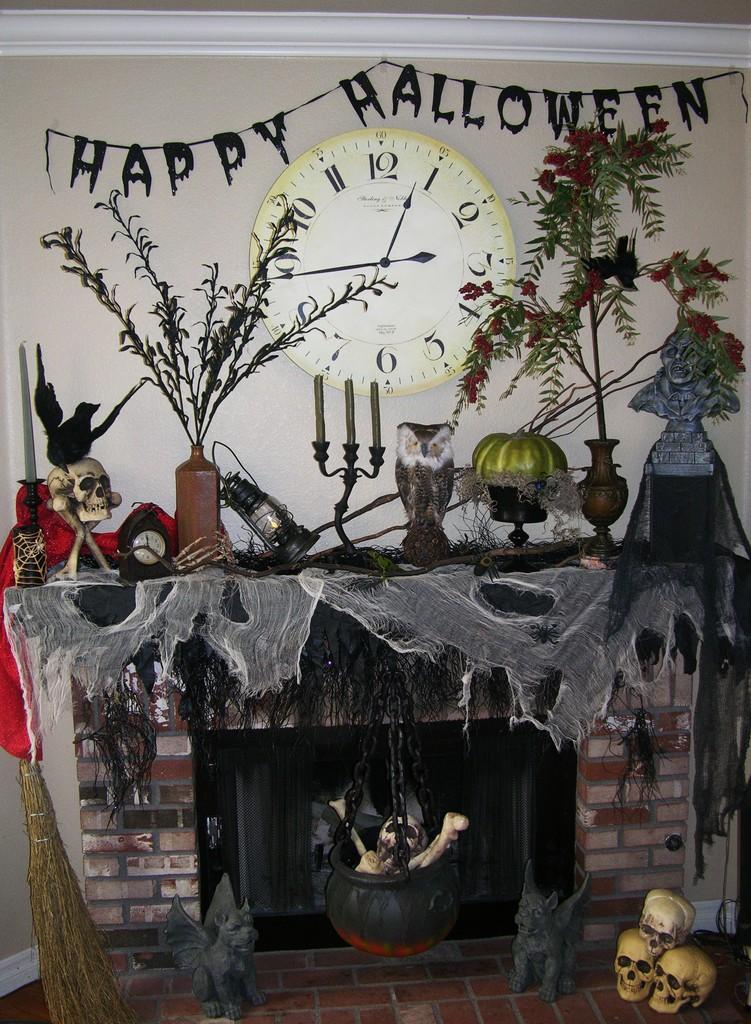Which holiday is being celebrated?
Ensure brevity in your answer.  Halloween. Why is the place looking so scary?
Ensure brevity in your answer.  Halloween. 